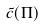<formula> <loc_0><loc_0><loc_500><loc_500>\tilde { c } ( \Pi )</formula> 